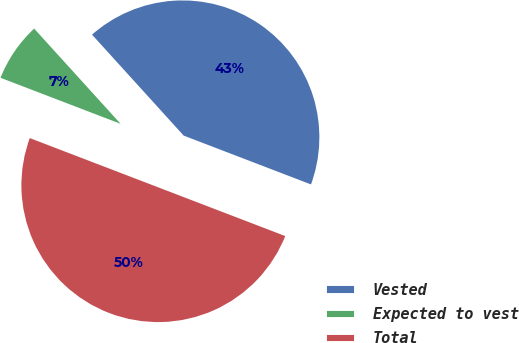Convert chart to OTSL. <chart><loc_0><loc_0><loc_500><loc_500><pie_chart><fcel>Vested<fcel>Expected to vest<fcel>Total<nl><fcel>42.56%<fcel>7.44%<fcel>50.0%<nl></chart> 